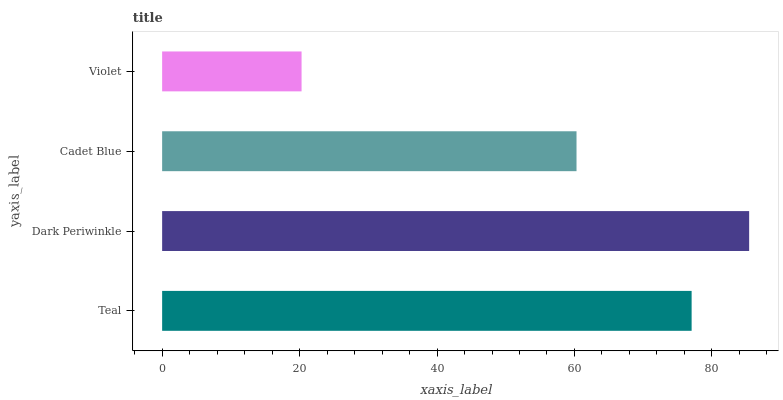Is Violet the minimum?
Answer yes or no. Yes. Is Dark Periwinkle the maximum?
Answer yes or no. Yes. Is Cadet Blue the minimum?
Answer yes or no. No. Is Cadet Blue the maximum?
Answer yes or no. No. Is Dark Periwinkle greater than Cadet Blue?
Answer yes or no. Yes. Is Cadet Blue less than Dark Periwinkle?
Answer yes or no. Yes. Is Cadet Blue greater than Dark Periwinkle?
Answer yes or no. No. Is Dark Periwinkle less than Cadet Blue?
Answer yes or no. No. Is Teal the high median?
Answer yes or no. Yes. Is Cadet Blue the low median?
Answer yes or no. Yes. Is Dark Periwinkle the high median?
Answer yes or no. No. Is Violet the low median?
Answer yes or no. No. 